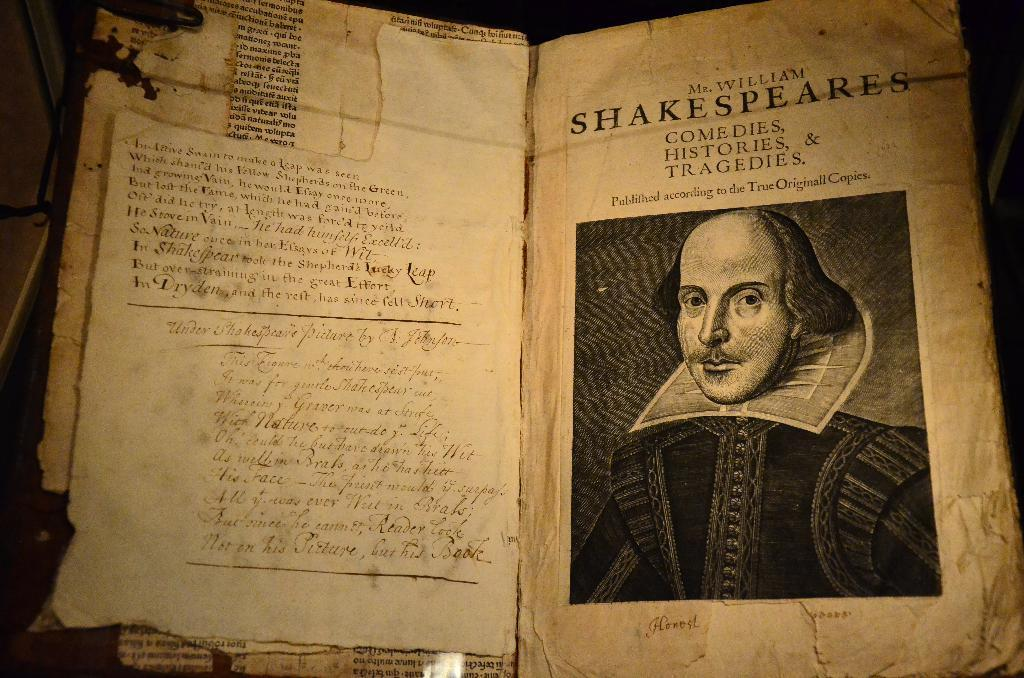What object is present in the image? There is a book in the image. What can be found within the book? The book contains a picture of a man and text. How does the horse increase its speed on the stage in the image? There is no horse or stage present in the image; it only features a book with a picture of a man and text. 